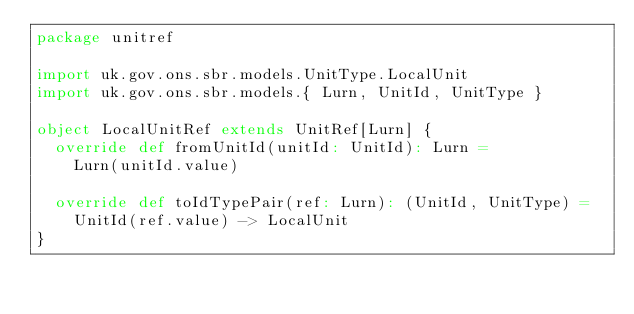Convert code to text. <code><loc_0><loc_0><loc_500><loc_500><_Scala_>package unitref

import uk.gov.ons.sbr.models.UnitType.LocalUnit
import uk.gov.ons.sbr.models.{ Lurn, UnitId, UnitType }

object LocalUnitRef extends UnitRef[Lurn] {
  override def fromUnitId(unitId: UnitId): Lurn =
    Lurn(unitId.value)

  override def toIdTypePair(ref: Lurn): (UnitId, UnitType) =
    UnitId(ref.value) -> LocalUnit
}
</code> 